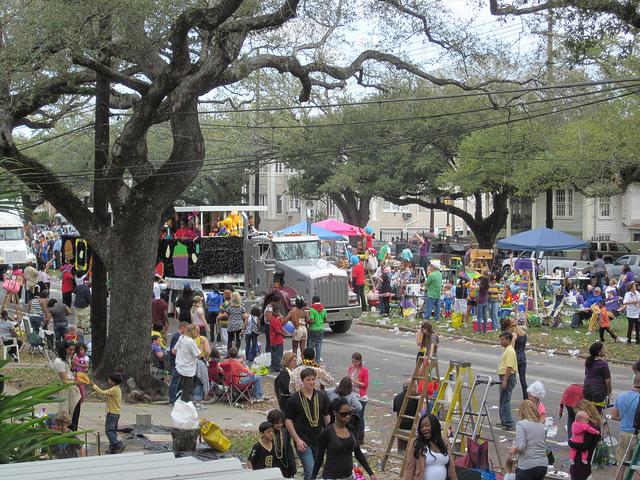What is this crowd going to watch?
Answer briefly. Parade. What is the color of the vehicle?
Short answer required. Gray. What is being celebrated here?
Keep it brief. Parade. Is the guy in the yellow shirt wearing a tie?
Quick response, please. No. How many ladders are there?
Short answer required. 3. Is there a lot of litter on the ground?
Answer briefly. Yes. Is this photo called a collage?
Answer briefly. No. 